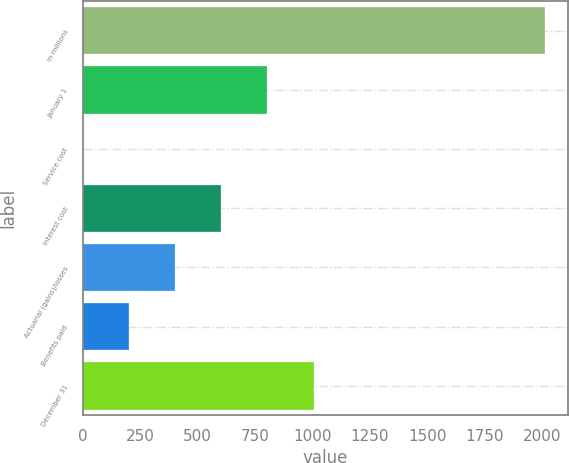<chart> <loc_0><loc_0><loc_500><loc_500><bar_chart><fcel>in millions<fcel>January 1<fcel>Service cost<fcel>Interest cost<fcel>Actuarial (gains)/losses<fcel>Benefits paid<fcel>December 31<nl><fcel>2010<fcel>804.36<fcel>0.6<fcel>603.42<fcel>402.48<fcel>201.54<fcel>1005.3<nl></chart> 